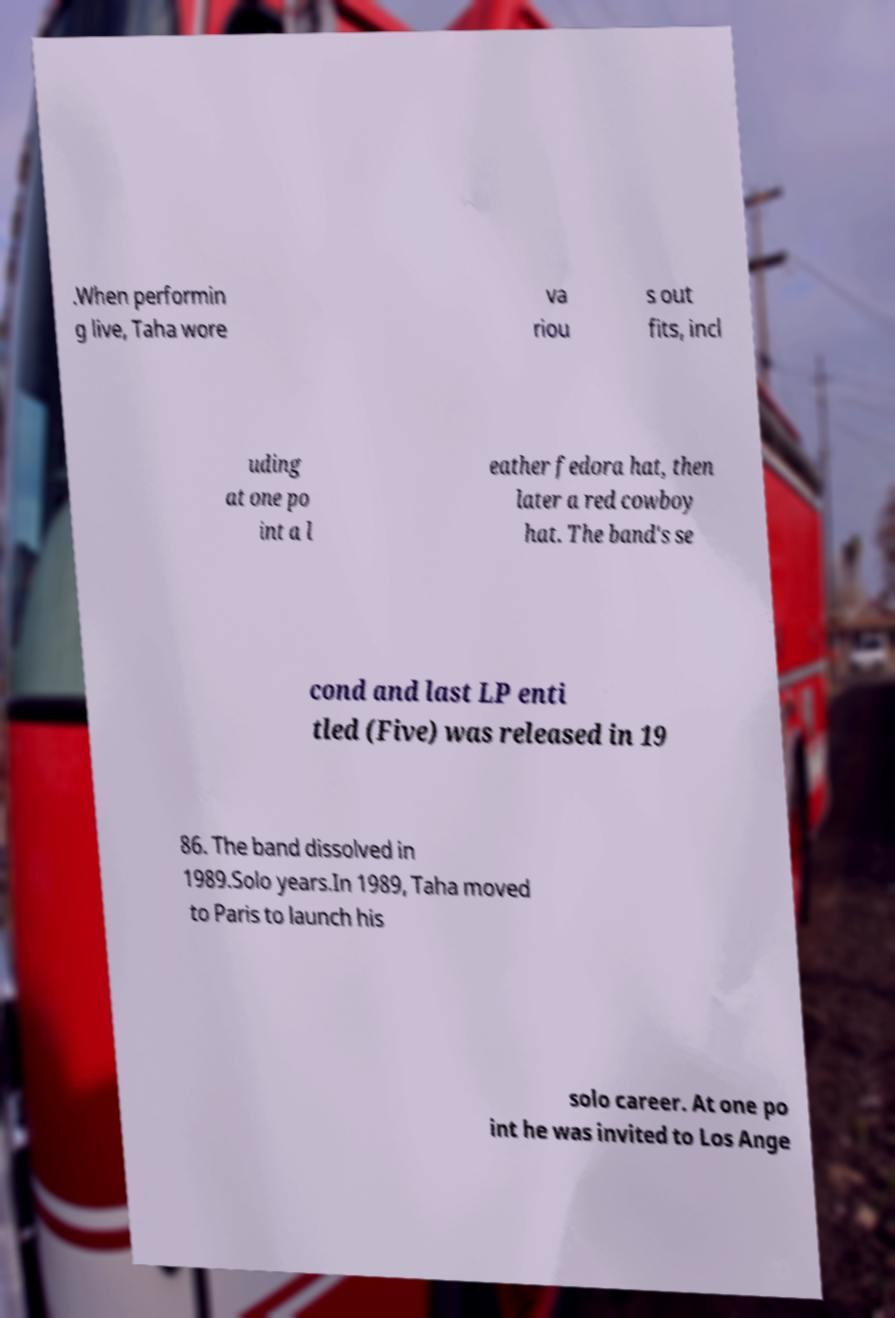Please read and relay the text visible in this image. What does it say? .When performin g live, Taha wore va riou s out fits, incl uding at one po int a l eather fedora hat, then later a red cowboy hat. The band's se cond and last LP enti tled (Five) was released in 19 86. The band dissolved in 1989.Solo years.In 1989, Taha moved to Paris to launch his solo career. At one po int he was invited to Los Ange 